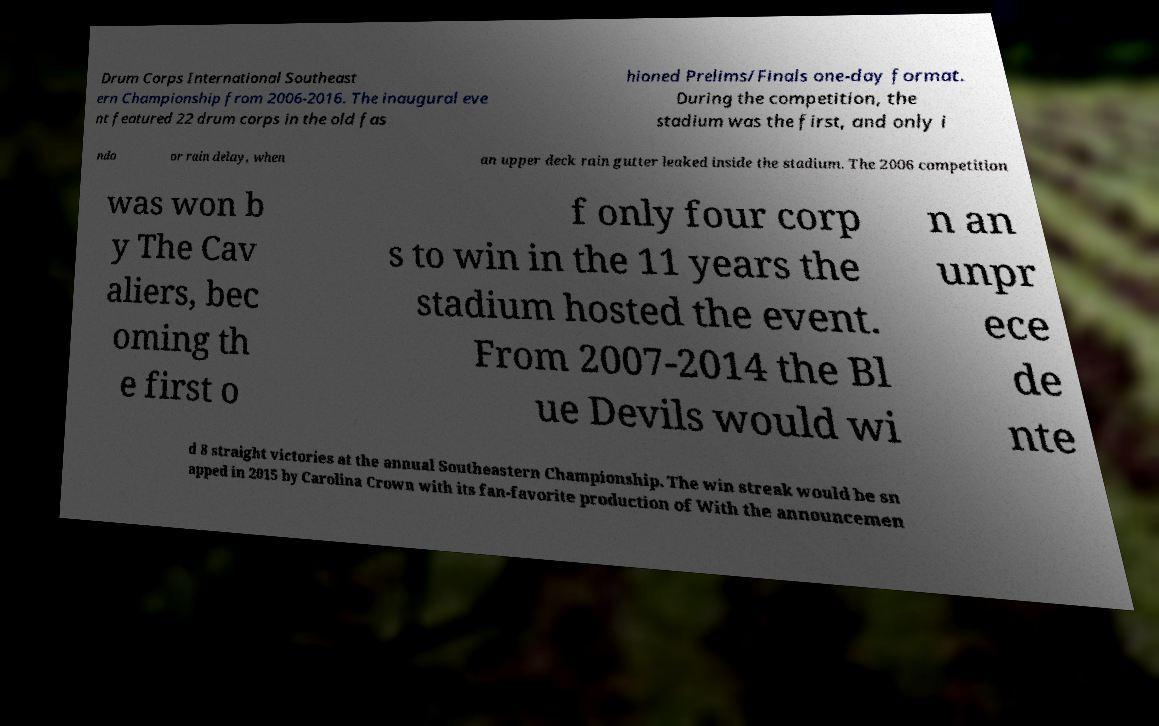Could you assist in decoding the text presented in this image and type it out clearly? Drum Corps International Southeast ern Championship from 2006-2016. The inaugural eve nt featured 22 drum corps in the old fas hioned Prelims/Finals one-day format. During the competition, the stadium was the first, and only i ndo or rain delay, when an upper deck rain gutter leaked inside the stadium. The 2006 competition was won b y The Cav aliers, bec oming th e first o f only four corp s to win in the 11 years the stadium hosted the event. From 2007-2014 the Bl ue Devils would wi n an unpr ece de nte d 8 straight victories at the annual Southeastern Championship. The win streak would be sn apped in 2015 by Carolina Crown with its fan-favorite production of With the announcemen 